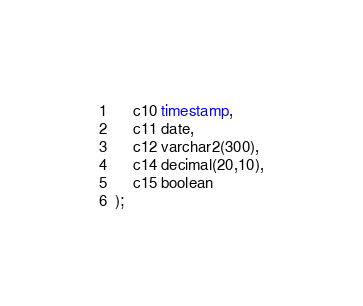<code> <loc_0><loc_0><loc_500><loc_500><_SQL_>    c10 timestamp,
    c11 date,
    c12 varchar2(300),
    c14 decimal(20,10),
    c15 boolean
);
</code> 